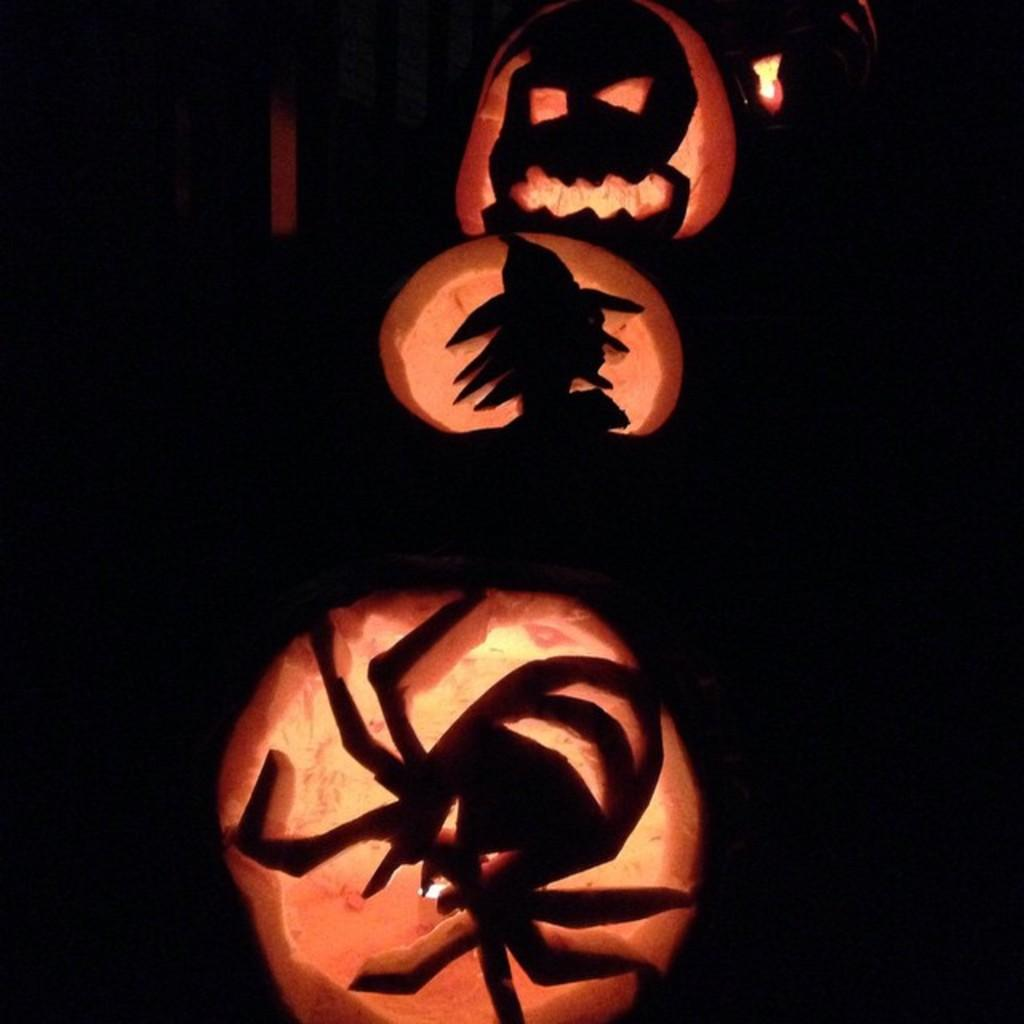What type of decorations are featured in the image? There are jack-o'-lanterns in the image. What can be observed about the lighting in the image? The background of the image is dark. What is the income of the person who made the jack-o'-lanterns in the image? There is no information about the person who made the jack-o'-lanterns or their income in the image. How much juice can be seen in the image? There is no juice present in the image. 